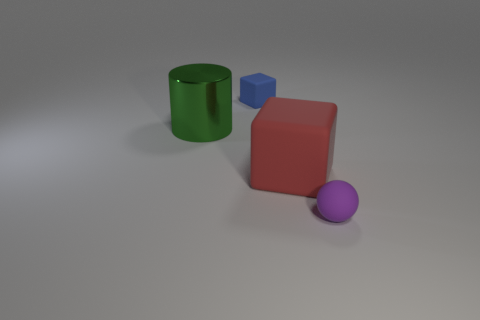Add 1 big purple metal things. How many objects exist? 5 Subtract all cylinders. How many objects are left? 3 Subtract all red blocks. Subtract all red objects. How many objects are left? 2 Add 3 small blocks. How many small blocks are left? 4 Add 2 purple rubber spheres. How many purple rubber spheres exist? 3 Subtract 0 blue cylinders. How many objects are left? 4 